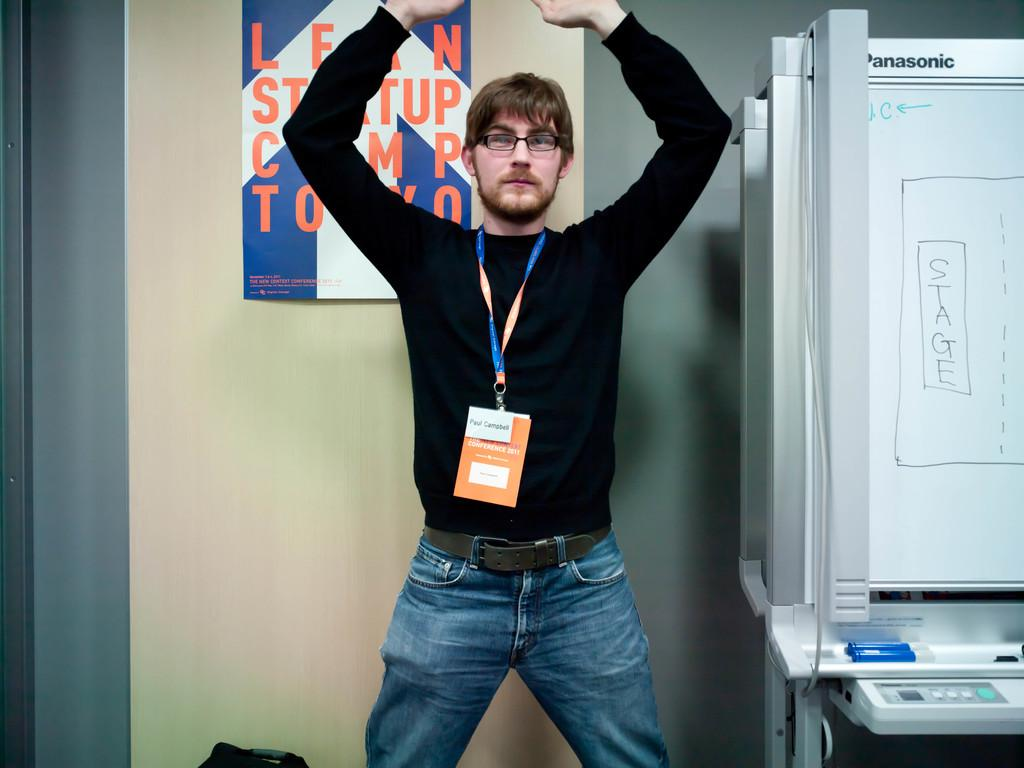Provide a one-sentence caption for the provided image. Planning room featuring a white board with the word stage written across it. 